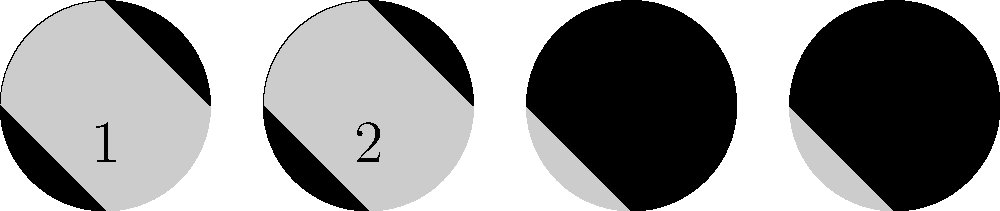As a sports journalism student who often debates hockey stats, you might appreciate the importance of timing and cycles in sports. In astronomy, the moon's phases follow a predictable cycle. Based on the images above, which number represents the First Quarter phase of the moon? To answer this question, let's break down the moon phases shown in the images:

1. Image 1 shows a completely dark moon, which represents the New Moon phase.
2. Image 2 shows a half-illuminated moon with the right side lit, which represents the First Quarter phase.
3. Image 3 shows a fully illuminated moon, which represents the Full Moon phase.
4. Image 4 shows a half-illuminated moon with the left side lit, which represents the Last Quarter phase.

The First Quarter phase occurs when the right half of the moon is illuminated from our perspective on Earth. This happens about a week after the New Moon, as the moon moves through its 29.5-day cycle.

In the context of sports journalism, understanding cycles and timing is crucial. Just as the moon's phases follow a predictable pattern, sports seasons and player performance often have their own cycles and rhythms that journalists need to be aware of when analyzing stats and trends.
Answer: 2 